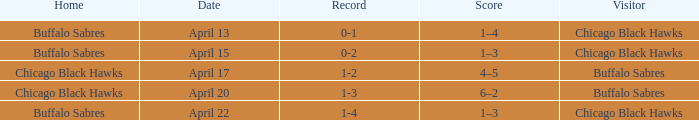When has a Record of 1-3? April 20. 